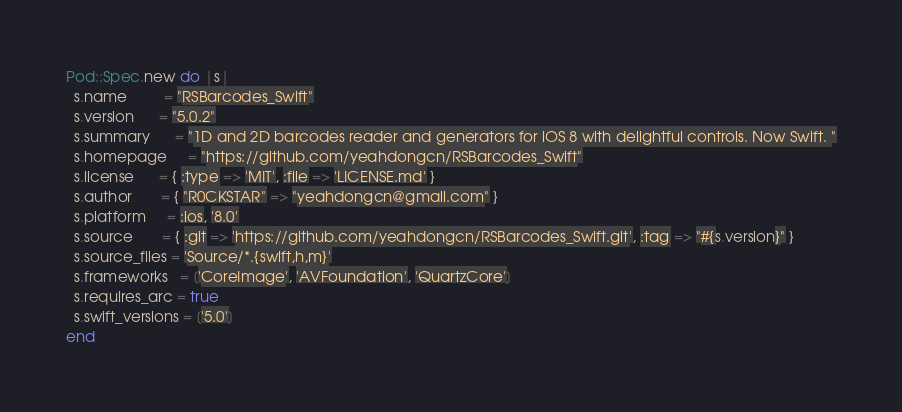Convert code to text. <code><loc_0><loc_0><loc_500><loc_500><_Ruby_>Pod::Spec.new do |s|
  s.name         = "RSBarcodes_Swift"
  s.version      = "5.0.2"
  s.summary      = "1D and 2D barcodes reader and generators for iOS 8 with delightful controls. Now Swift. "
  s.homepage     = "https://github.com/yeahdongcn/RSBarcodes_Swift"
  s.license      = { :type => 'MIT', :file => 'LICENSE.md' }
  s.author       = { "R0CKSTAR" => "yeahdongcn@gmail.com" }
  s.platform     = :ios, '8.0'
  s.source       = { :git => 'https://github.com/yeahdongcn/RSBarcodes_Swift.git', :tag => "#{s.version}" }
  s.source_files = 'Source/*.{swift,h,m}'
  s.frameworks   = ['CoreImage', 'AVFoundation', 'QuartzCore']
  s.requires_arc = true
  s.swift_versions = ['5.0']
end
</code> 